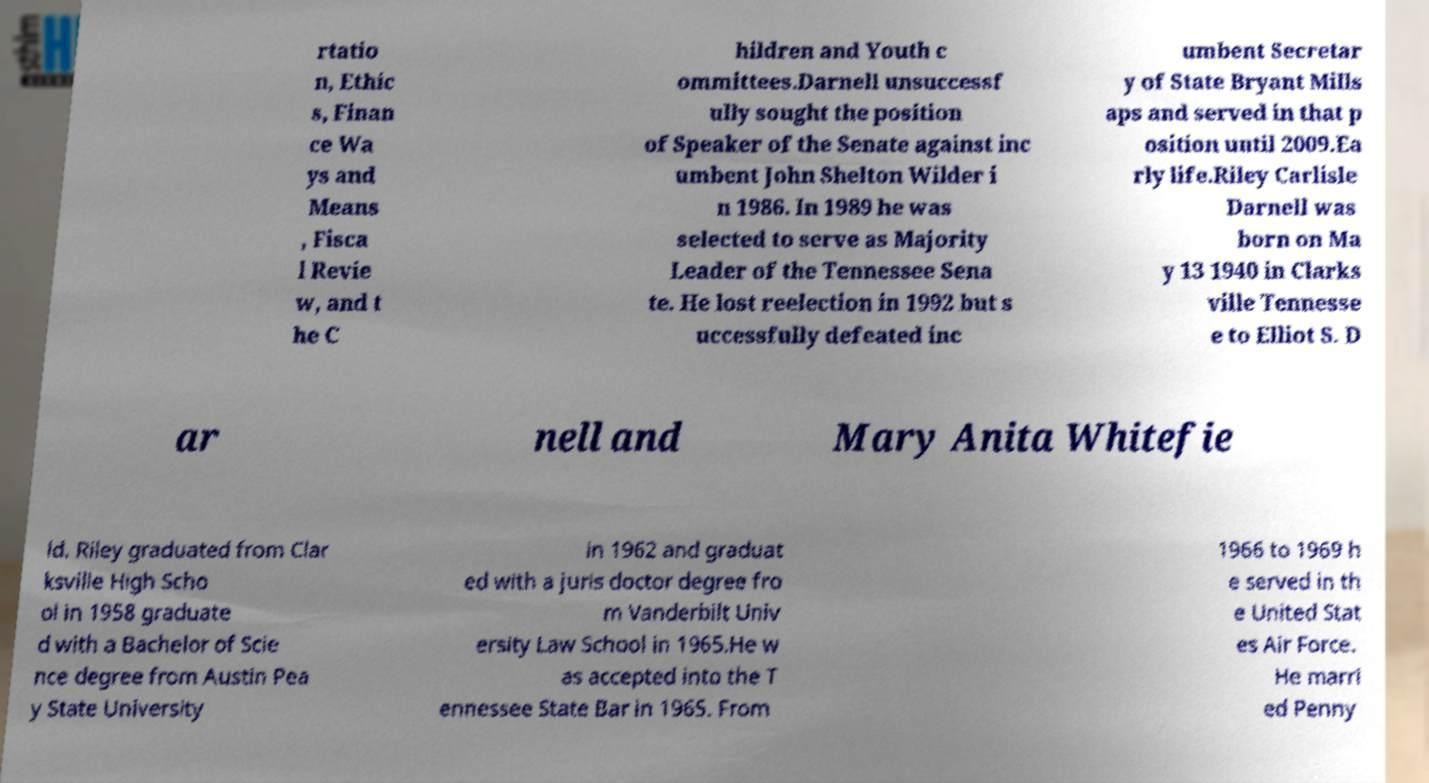What messages or text are displayed in this image? I need them in a readable, typed format. rtatio n, Ethic s, Finan ce Wa ys and Means , Fisca l Revie w, and t he C hildren and Youth c ommittees.Darnell unsuccessf ully sought the position of Speaker of the Senate against inc umbent John Shelton Wilder i n 1986. In 1989 he was selected to serve as Majority Leader of the Tennessee Sena te. He lost reelection in 1992 but s uccessfully defeated inc umbent Secretar y of State Bryant Mills aps and served in that p osition until 2009.Ea rly life.Riley Carlisle Darnell was born on Ma y 13 1940 in Clarks ville Tennesse e to Elliot S. D ar nell and Mary Anita Whitefie ld. Riley graduated from Clar ksville High Scho ol in 1958 graduate d with a Bachelor of Scie nce degree from Austin Pea y State University in 1962 and graduat ed with a juris doctor degree fro m Vanderbilt Univ ersity Law School in 1965.He w as accepted into the T ennessee State Bar in 1965. From 1966 to 1969 h e served in th e United Stat es Air Force. He marri ed Penny 